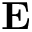<formula> <loc_0><loc_0><loc_500><loc_500>{ E }</formula> 